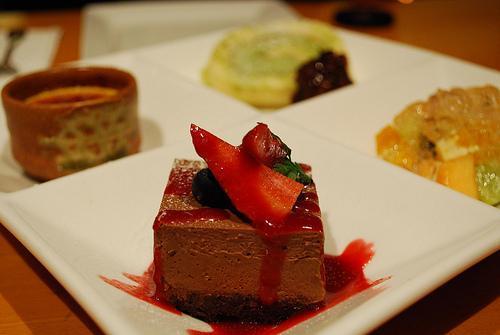How many plates are on the table?
Give a very brief answer. 4. 